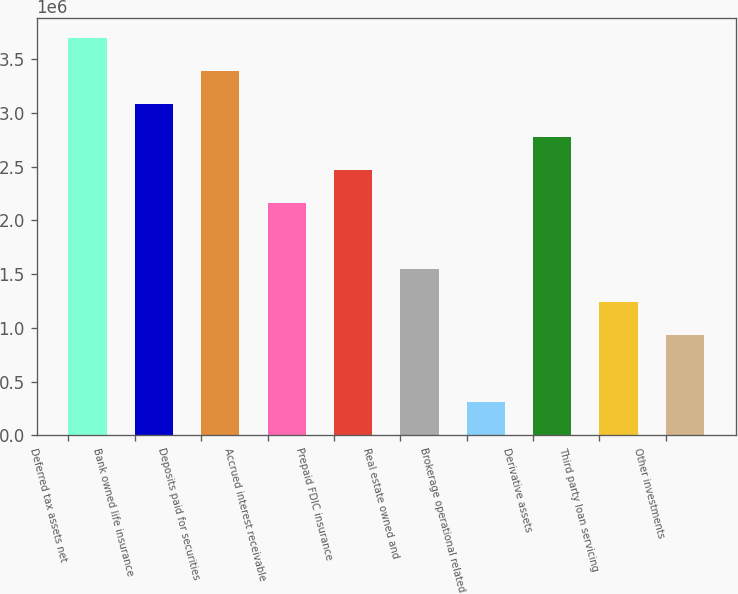Convert chart. <chart><loc_0><loc_0><loc_500><loc_500><bar_chart><fcel>Deferred tax assets net<fcel>Bank owned life insurance<fcel>Deposits paid for securities<fcel>Accrued interest receivable<fcel>Prepaid FDIC insurance<fcel>Real estate owned and<fcel>Brokerage operational related<fcel>Derivative assets<fcel>Third party loan servicing<fcel>Other investments<nl><fcel>3.69931e+06<fcel>3.08367e+06<fcel>3.39149e+06<fcel>2.16021e+06<fcel>2.46803e+06<fcel>1.54457e+06<fcel>313291<fcel>2.77585e+06<fcel>1.23675e+06<fcel>928932<nl></chart> 